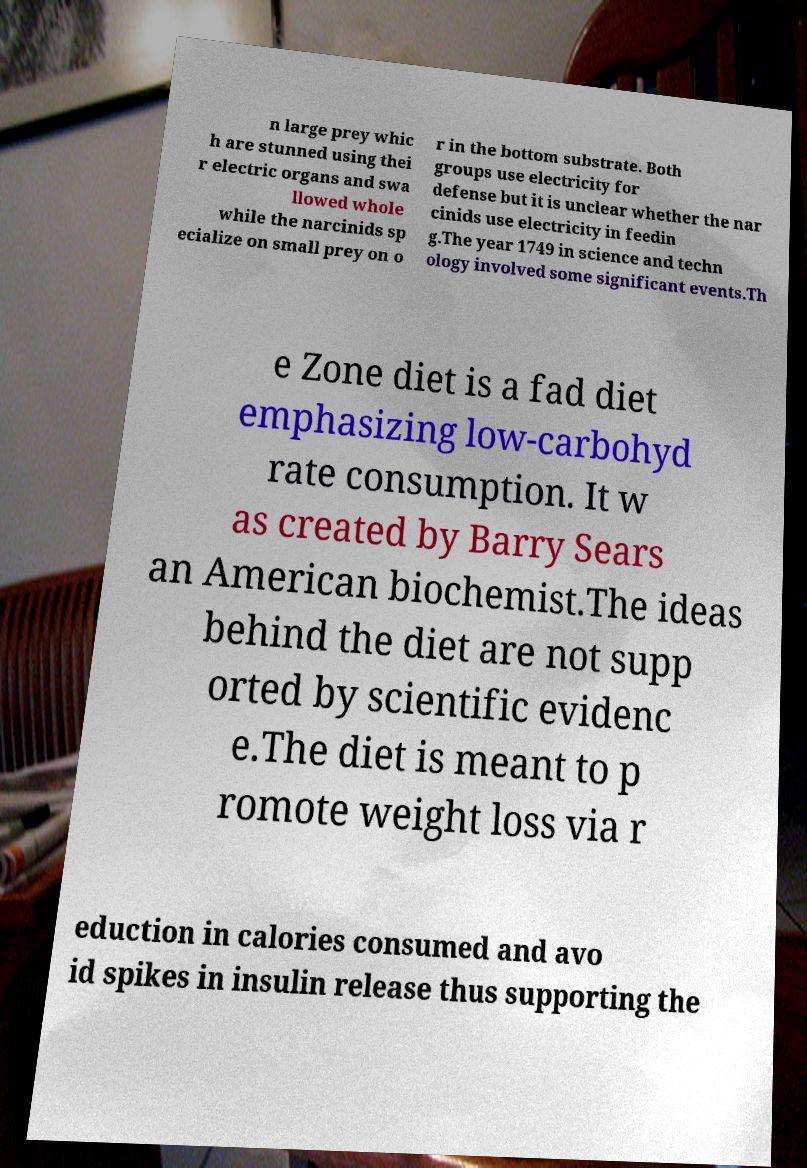There's text embedded in this image that I need extracted. Can you transcribe it verbatim? n large prey whic h are stunned using thei r electric organs and swa llowed whole while the narcinids sp ecialize on small prey on o r in the bottom substrate. Both groups use electricity for defense but it is unclear whether the nar cinids use electricity in feedin g.The year 1749 in science and techn ology involved some significant events.Th e Zone diet is a fad diet emphasizing low-carbohyd rate consumption. It w as created by Barry Sears an American biochemist.The ideas behind the diet are not supp orted by scientific evidenc e.The diet is meant to p romote weight loss via r eduction in calories consumed and avo id spikes in insulin release thus supporting the 